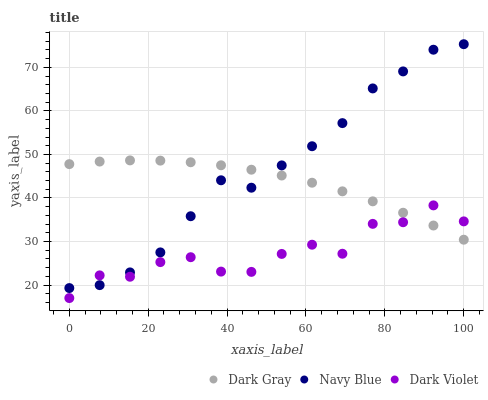Does Dark Violet have the minimum area under the curve?
Answer yes or no. Yes. Does Navy Blue have the maximum area under the curve?
Answer yes or no. Yes. Does Navy Blue have the minimum area under the curve?
Answer yes or no. No. Does Dark Violet have the maximum area under the curve?
Answer yes or no. No. Is Dark Gray the smoothest?
Answer yes or no. Yes. Is Dark Violet the roughest?
Answer yes or no. Yes. Is Navy Blue the smoothest?
Answer yes or no. No. Is Navy Blue the roughest?
Answer yes or no. No. Does Dark Violet have the lowest value?
Answer yes or no. Yes. Does Navy Blue have the lowest value?
Answer yes or no. No. Does Navy Blue have the highest value?
Answer yes or no. Yes. Does Dark Violet have the highest value?
Answer yes or no. No. Does Dark Gray intersect Dark Violet?
Answer yes or no. Yes. Is Dark Gray less than Dark Violet?
Answer yes or no. No. Is Dark Gray greater than Dark Violet?
Answer yes or no. No. 